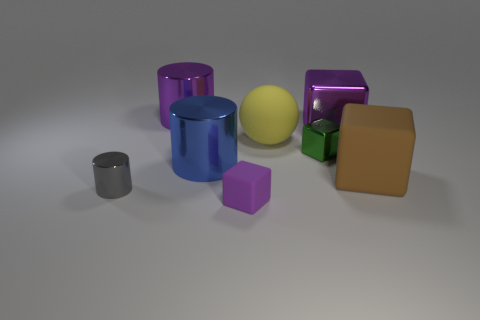There is a tiny object to the left of the large purple shiny cylinder; is it the same shape as the blue metallic thing?
Keep it short and to the point. Yes. Is there a thing that has the same size as the gray metallic cylinder?
Your answer should be very brief. Yes. There is a gray metallic object; is it the same shape as the small object that is behind the blue cylinder?
Keep it short and to the point. No. What shape is the metal object that is the same color as the large metal cube?
Your answer should be very brief. Cylinder. Are there fewer large brown things to the left of the big brown object than gray metallic things?
Make the answer very short. Yes. Does the small gray object have the same shape as the small green thing?
Ensure brevity in your answer.  No. There is a purple block that is the same material as the gray cylinder; what size is it?
Make the answer very short. Large. Is the number of large cyan cylinders less than the number of yellow rubber things?
Offer a terse response. Yes. What number of tiny things are either brown cylinders or blue objects?
Offer a terse response. 0. How many small metal objects are in front of the brown matte thing and behind the brown rubber block?
Offer a very short reply. 0. 